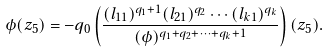Convert formula to latex. <formula><loc_0><loc_0><loc_500><loc_500>\phi ( z _ { 5 } ) = - q _ { 0 } \left ( \frac { ( l _ { 1 1 } ) ^ { q _ { 1 } + 1 } ( l _ { 2 1 } ) ^ { q _ { 2 } } \cdots ( l _ { k 1 } ) ^ { q _ { k } } } { ( \phi ) ^ { q _ { 1 } + q _ { 2 } + \cdots + q _ { k } + 1 } } \right ) ( z _ { 5 } ) .</formula> 